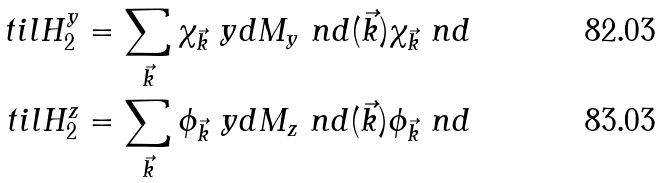Convert formula to latex. <formula><loc_0><loc_0><loc_500><loc_500>\ t i l H ^ { y } _ { 2 } & = \sum _ { \vec { k } } { \chi _ { \vec { k } } \ y d M _ { y } \ n d ( \vec { k } ) \chi _ { \vec { k } } \ n d } \\ \ t i l H ^ { z } _ { 2 } & = \sum _ { \vec { k } } { \phi _ { \vec { k } } \ y d M _ { z } \ n d ( \vec { k } ) \phi _ { \vec { k } } \ n d }</formula> 